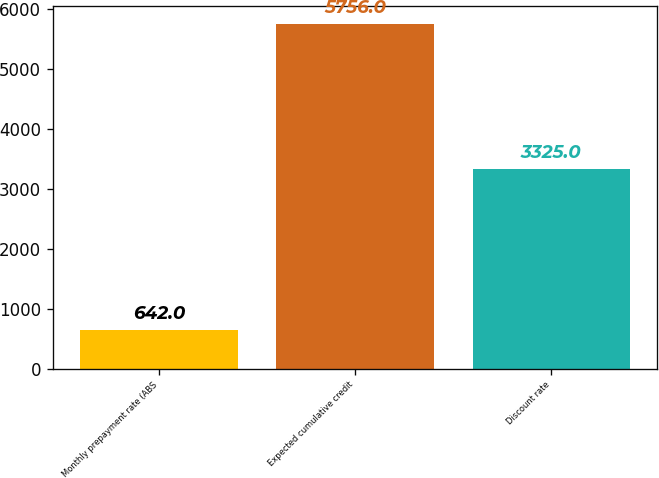Convert chart to OTSL. <chart><loc_0><loc_0><loc_500><loc_500><bar_chart><fcel>Monthly prepayment rate (ABS<fcel>Expected cumulative credit<fcel>Discount rate<nl><fcel>642<fcel>5756<fcel>3325<nl></chart> 